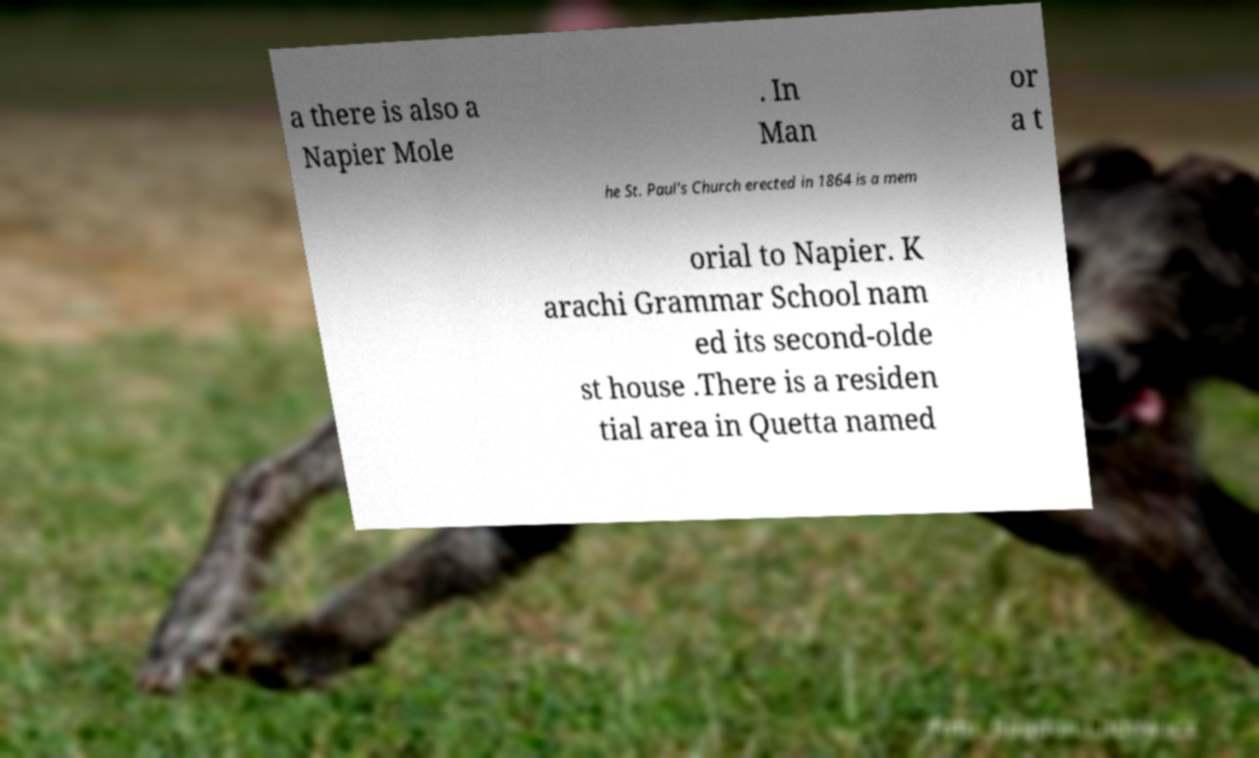Please identify and transcribe the text found in this image. a there is also a Napier Mole . In Man or a t he St. Paul's Church erected in 1864 is a mem orial to Napier. K arachi Grammar School nam ed its second-olde st house .There is a residen tial area in Quetta named 